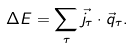<formula> <loc_0><loc_0><loc_500><loc_500>\Delta E = \sum _ { \tau } \vec { j } _ { \tau } \cdot \vec { q } _ { \tau } .</formula> 